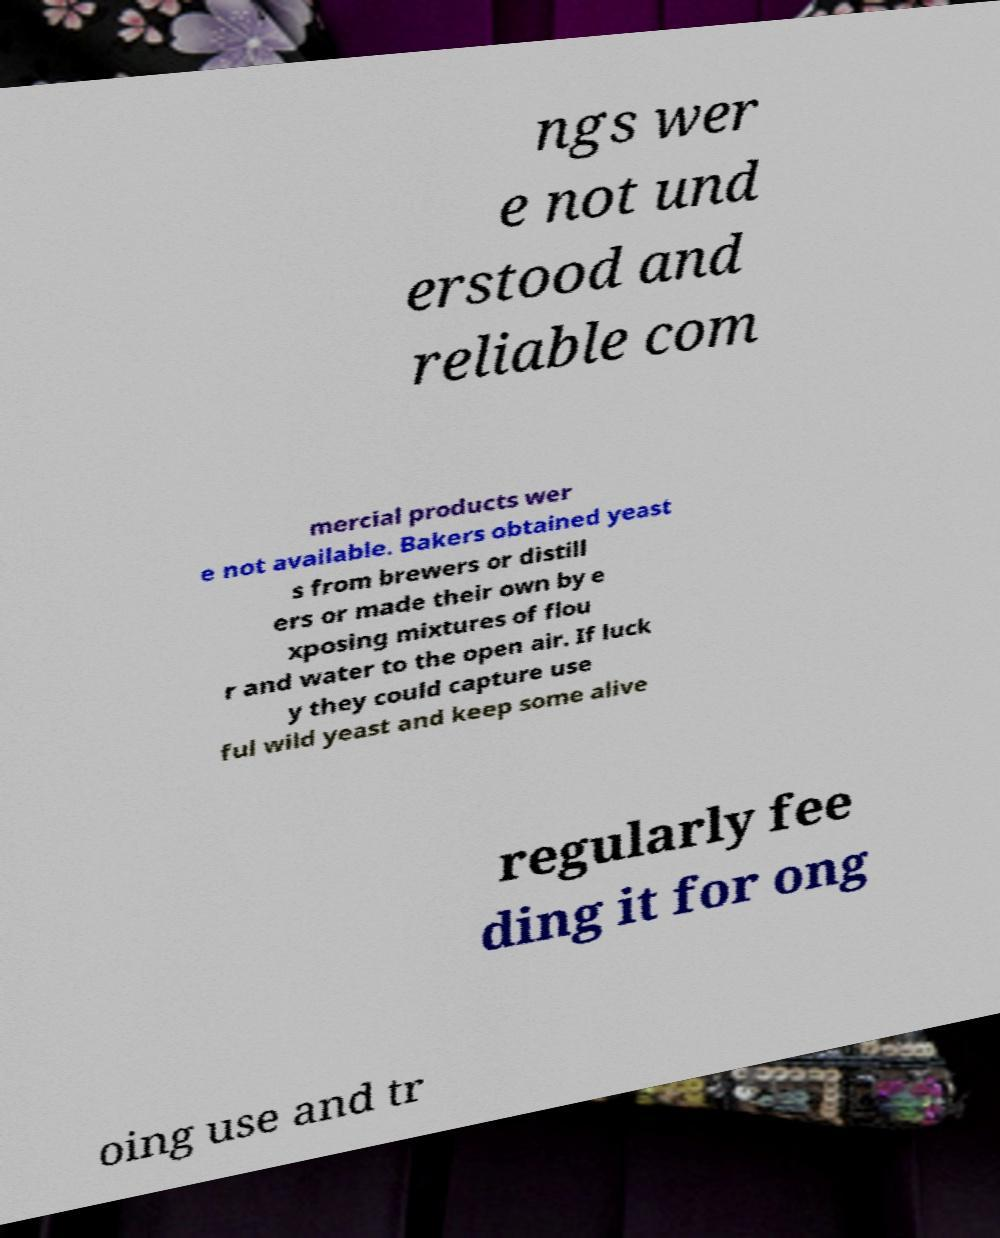Please read and relay the text visible in this image. What does it say? ngs wer e not und erstood and reliable com mercial products wer e not available. Bakers obtained yeast s from brewers or distill ers or made their own by e xposing mixtures of flou r and water to the open air. If luck y they could capture use ful wild yeast and keep some alive regularly fee ding it for ong oing use and tr 